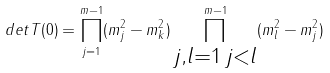Convert formula to latex. <formula><loc_0><loc_0><loc_500><loc_500>d e t T ( 0 ) = \prod _ { j = 1 } ^ { m - 1 } ( m _ { j } ^ { 2 } - m _ { k } ^ { 2 } ) \prod _ { \substack { j , l = 1 \, j < l } } ^ { m - 1 } ( m _ { l } ^ { 2 } - m _ { j } ^ { 2 } )</formula> 